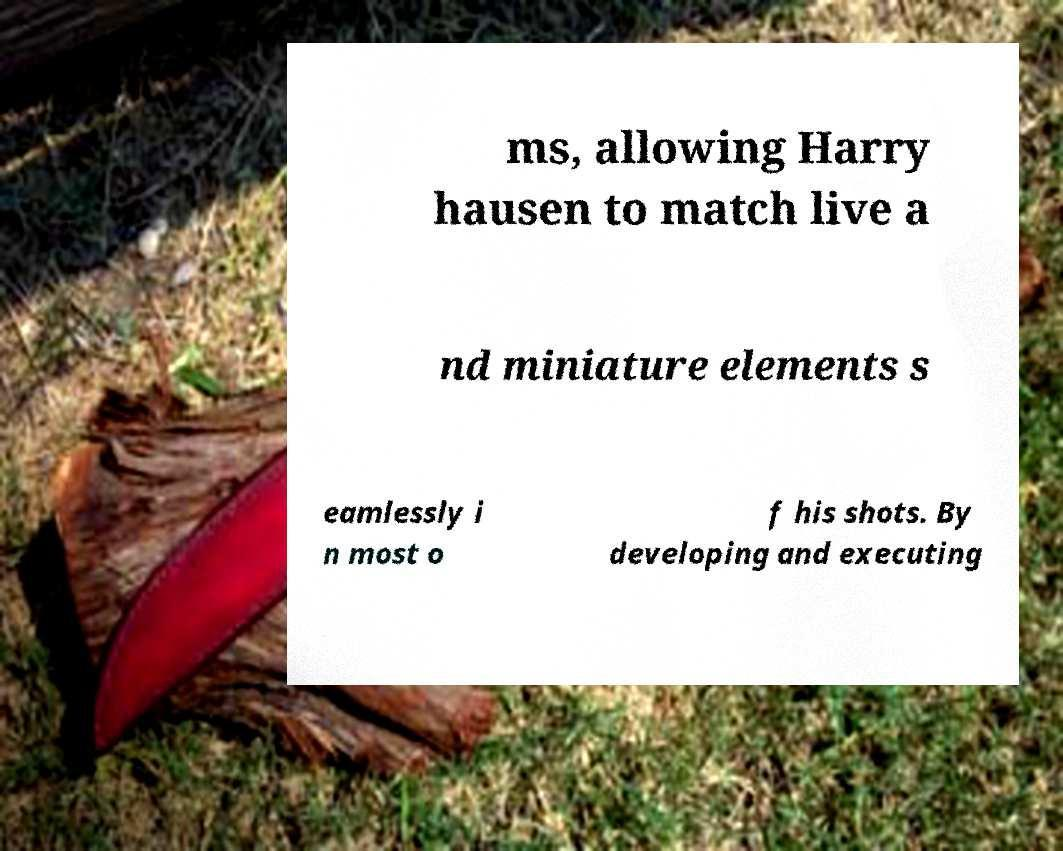Could you extract and type out the text from this image? ms, allowing Harry hausen to match live a nd miniature elements s eamlessly i n most o f his shots. By developing and executing 